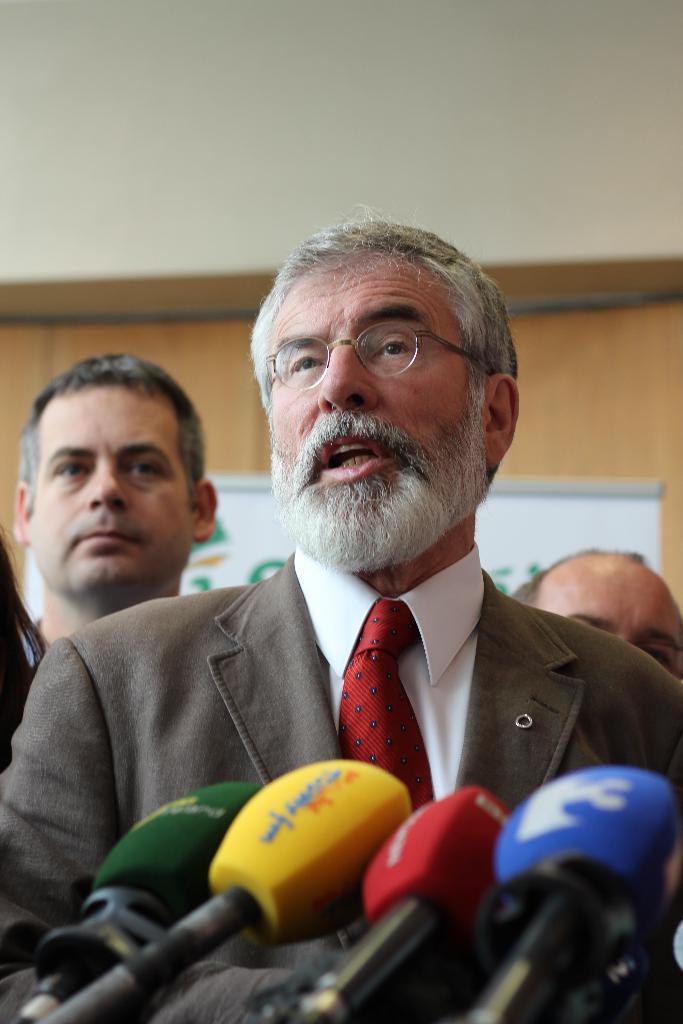Please provide a concise description of this image. In front of the image there are mike's. There are people. In the background of the image there is a board and there is a wall. 